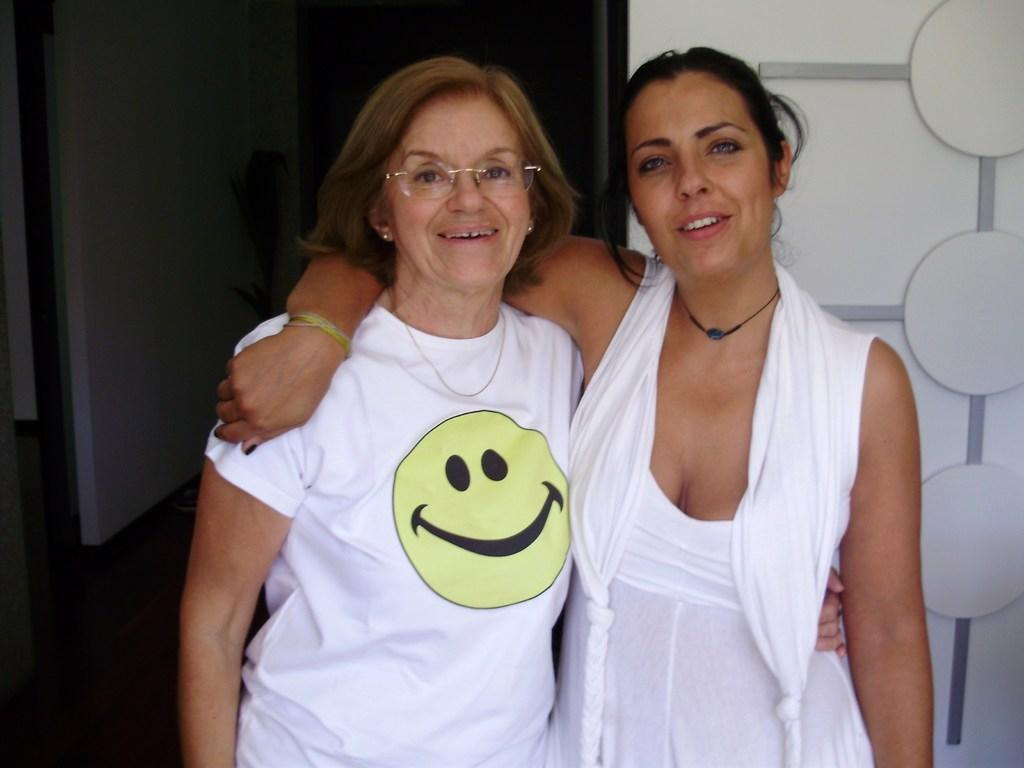How many people are in the image? There are two people in the image. What expressions do the people have on their faces? The people are wearing smiles on their faces. What can be seen in the background of the image? There is a wall visible in the background of the image. What type of bubble is being used by the secretary in the image? There is no secretary or bubble present in the image. 